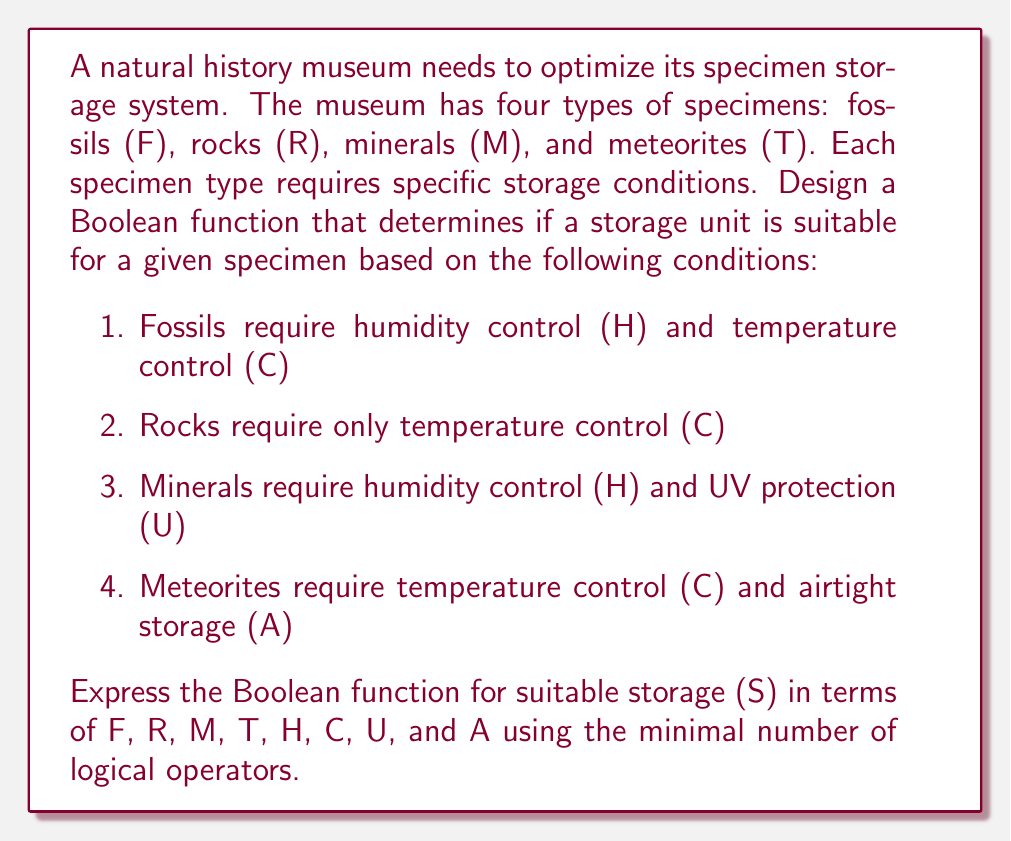Could you help me with this problem? Let's approach this step-by-step:

1. First, we'll write out the Boolean expressions for each specimen type:

   Fossils: $F \cdot H \cdot C$
   Rocks: $R \cdot C$
   Minerals: $M \cdot H \cdot U$
   Meteorites: $T \cdot C \cdot A$

2. The overall function for suitable storage (S) is the OR of all these conditions:

   $S = (F \cdot H \cdot C) + (R \cdot C) + (M \cdot H \cdot U) + (T \cdot C \cdot A)$

3. We can factor out common terms to simplify:

   $S = C \cdot (F \cdot H + R) + H \cdot (M \cdot U) + C \cdot (T \cdot A)$

4. Further simplification isn't possible without losing information, so this is our final, optimized Boolean function.

This function determines if a storage unit is suitable (S) based on the specimen type (F, R, M, or T) and the available storage conditions (H, C, U, A).
Answer: $S = C \cdot (F \cdot H + R) + H \cdot (M \cdot U) + C \cdot (T \cdot A)$ 